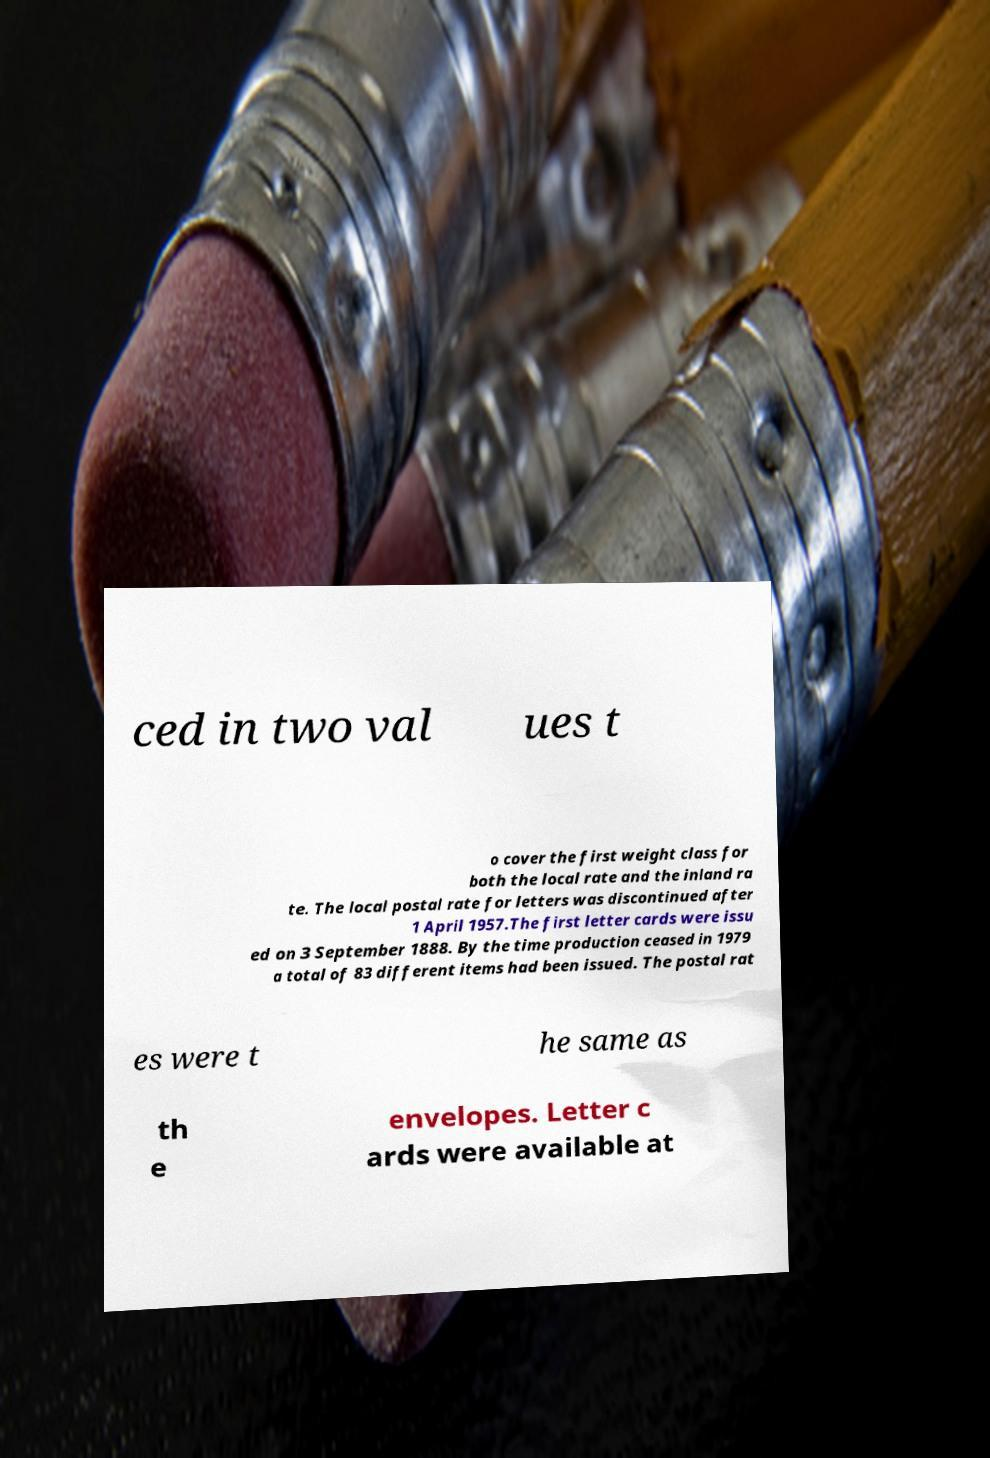Please identify and transcribe the text found in this image. ced in two val ues t o cover the first weight class for both the local rate and the inland ra te. The local postal rate for letters was discontinued after 1 April 1957.The first letter cards were issu ed on 3 September 1888. By the time production ceased in 1979 a total of 83 different items had been issued. The postal rat es were t he same as th e envelopes. Letter c ards were available at 